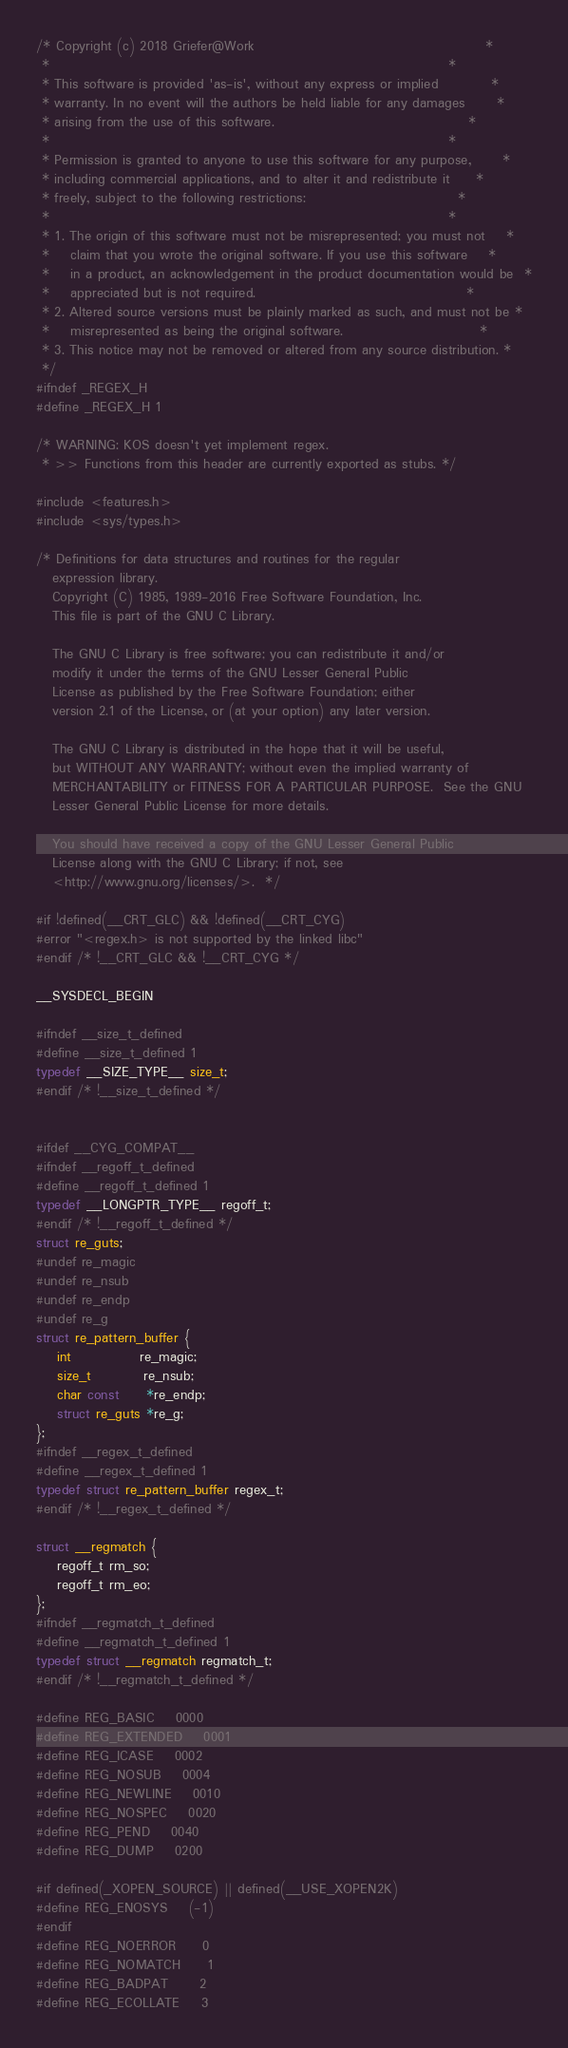<code> <loc_0><loc_0><loc_500><loc_500><_C_>/* Copyright (c) 2018 Griefer@Work                                            *
 *                                                                            *
 * This software is provided 'as-is', without any express or implied          *
 * warranty. In no event will the authors be held liable for any damages      *
 * arising from the use of this software.                                     *
 *                                                                            *
 * Permission is granted to anyone to use this software for any purpose,      *
 * including commercial applications, and to alter it and redistribute it     *
 * freely, subject to the following restrictions:                             *
 *                                                                            *
 * 1. The origin of this software must not be misrepresented; you must not    *
 *    claim that you wrote the original software. If you use this software    *
 *    in a product, an acknowledgement in the product documentation would be  *
 *    appreciated but is not required.                                        *
 * 2. Altered source versions must be plainly marked as such, and must not be *
 *    misrepresented as being the original software.                          *
 * 3. This notice may not be removed or altered from any source distribution. *
 */
#ifndef _REGEX_H
#define _REGEX_H 1

/* WARNING: KOS doesn't yet implement regex.
 * >> Functions from this header are currently exported as stubs. */

#include <features.h>
#include <sys/types.h>

/* Definitions for data structures and routines for the regular
   expression library.
   Copyright (C) 1985, 1989-2016 Free Software Foundation, Inc.
   This file is part of the GNU C Library.

   The GNU C Library is free software; you can redistribute it and/or
   modify it under the terms of the GNU Lesser General Public
   License as published by the Free Software Foundation; either
   version 2.1 of the License, or (at your option) any later version.

   The GNU C Library is distributed in the hope that it will be useful,
   but WITHOUT ANY WARRANTY; without even the implied warranty of
   MERCHANTABILITY or FITNESS FOR A PARTICULAR PURPOSE.  See the GNU
   Lesser General Public License for more details.

   You should have received a copy of the GNU Lesser General Public
   License along with the GNU C Library; if not, see
   <http://www.gnu.org/licenses/>.  */

#if !defined(__CRT_GLC) && !defined(__CRT_CYG)
#error "<regex.h> is not supported by the linked libc"
#endif /* !__CRT_GLC && !__CRT_CYG */

__SYSDECL_BEGIN

#ifndef __size_t_defined
#define __size_t_defined 1
typedef __SIZE_TYPE__ size_t;
#endif /* !__size_t_defined */


#ifdef __CYG_COMPAT__
#ifndef __regoff_t_defined
#define __regoff_t_defined 1
typedef __LONGPTR_TYPE__ regoff_t;
#endif /* !__regoff_t_defined */
struct re_guts;
#undef re_magic
#undef re_nsub
#undef re_endp
#undef re_g
struct re_pattern_buffer {
    int             re_magic;
    size_t          re_nsub;
    char const     *re_endp;
    struct re_guts *re_g;
};
#ifndef __regex_t_defined
#define __regex_t_defined 1
typedef struct re_pattern_buffer regex_t;
#endif /* !__regex_t_defined */

struct __regmatch {
    regoff_t rm_so;
    regoff_t rm_eo;
};
#ifndef __regmatch_t_defined
#define __regmatch_t_defined 1
typedef struct __regmatch regmatch_t;
#endif /* !__regmatch_t_defined */

#define REG_BASIC    0000
#define REG_EXTENDED    0001
#define REG_ICASE    0002
#define REG_NOSUB    0004
#define REG_NEWLINE    0010
#define REG_NOSPEC    0020
#define REG_PEND    0040
#define REG_DUMP    0200

#if defined(_XOPEN_SOURCE) || defined(__USE_XOPEN2K)
#define REG_ENOSYS    (-1)
#endif
#define REG_NOERROR     0
#define REG_NOMATCH     1
#define REG_BADPAT      2
#define REG_ECOLLATE    3</code> 